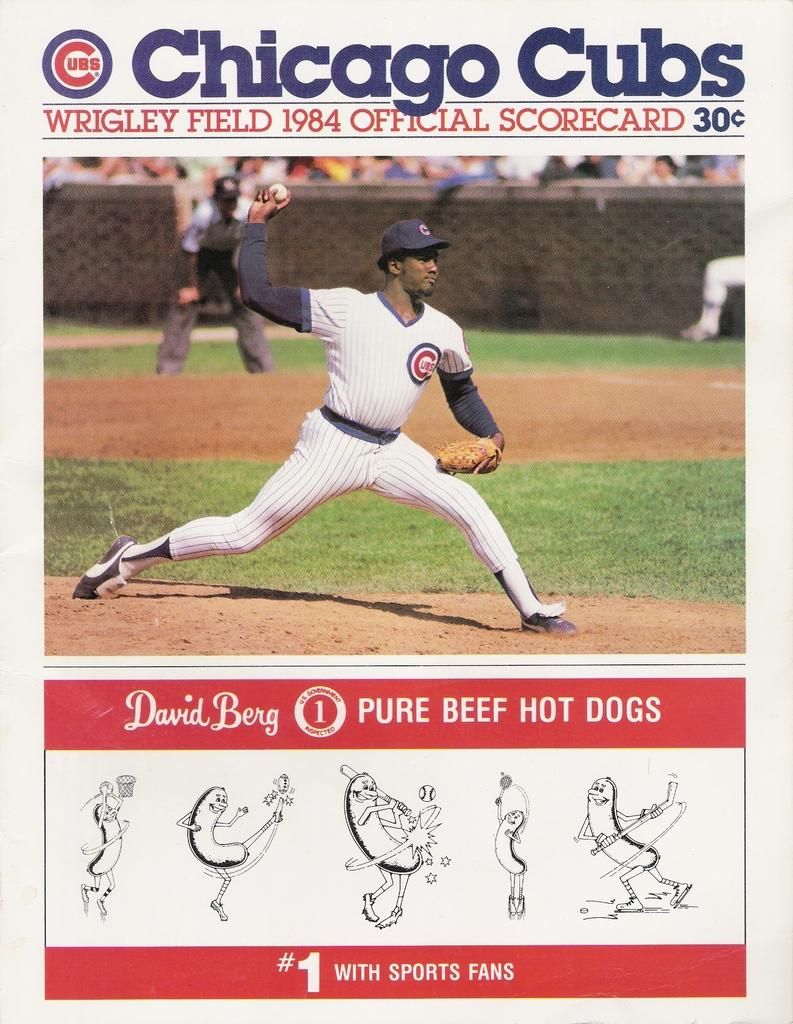Provide a one-sentence caption for the provided image. An official Chicago Cubs scorecard from 1984 contains an ad for David Berg beef hotdogs. 